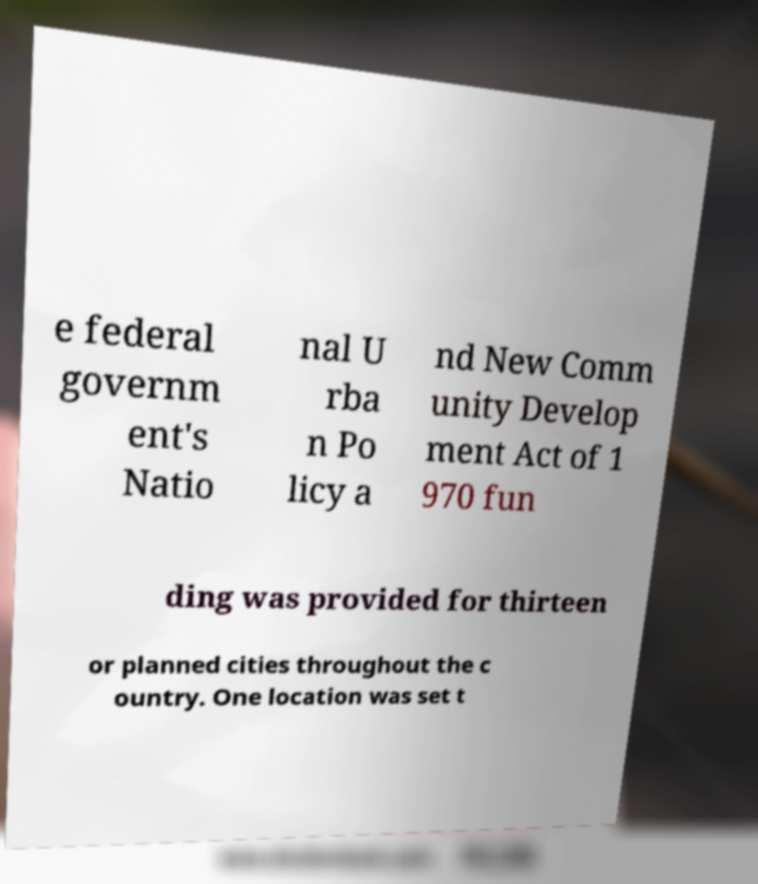Please identify and transcribe the text found in this image. e federal governm ent's Natio nal U rba n Po licy a nd New Comm unity Develop ment Act of 1 970 fun ding was provided for thirteen or planned cities throughout the c ountry. One location was set t 